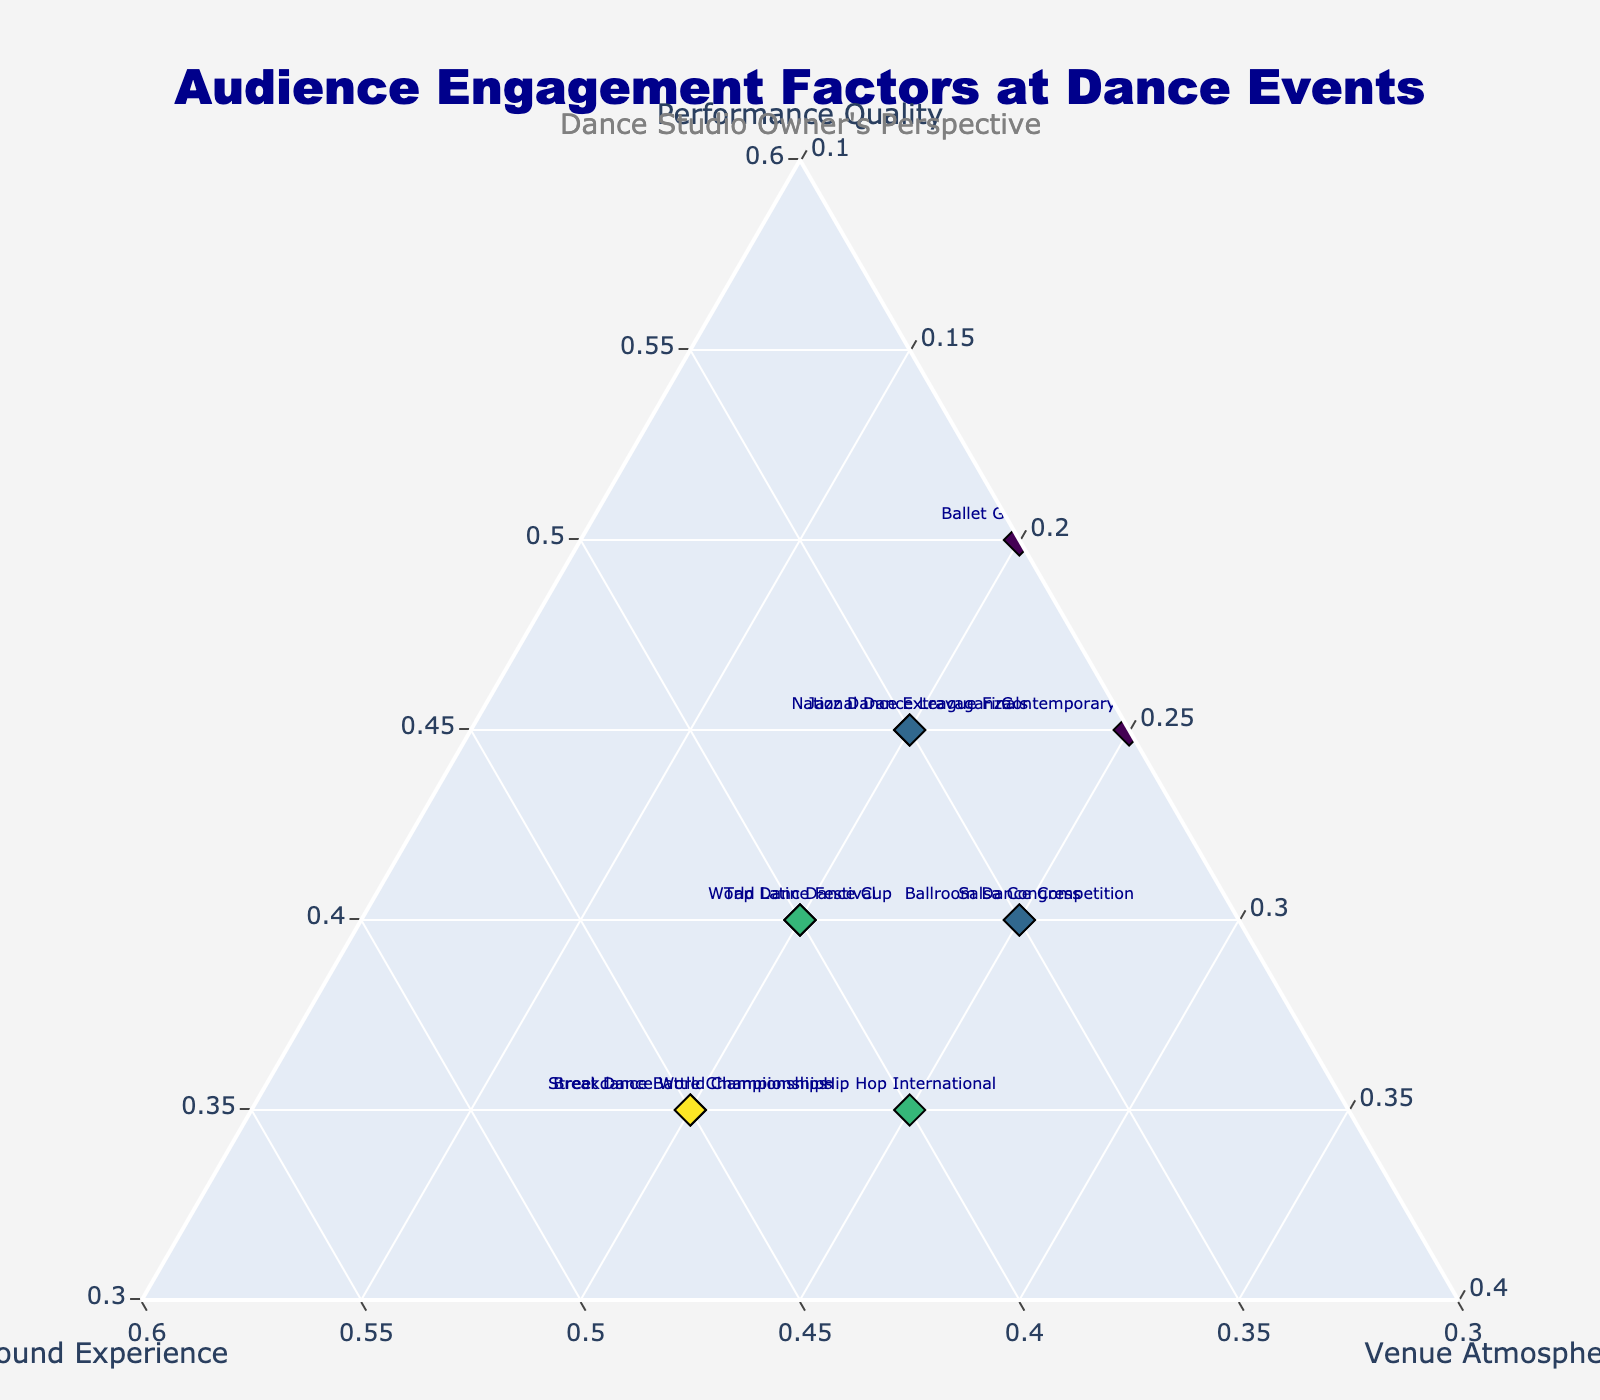what is the title of the plot? The title is usually at the top center of the plot and is written in bold or larger fonts. Looking at the plot, the title reads "Audience Engagement Factors at Dance Events".
Answer: Audience Engagement Factors at Dance Events how many events are displayed on the plot? The plot shows different events marked by text and points. Counting all the text labels for different events will give the total number, which is 11.
Answer: 11 which event has the highest sound experience score? Observing the 'Sound Experience' axis and looking for the event with the marker closest to the maximum value, the 'Breakdance Battle Championships' and 'Street Dance World Championships' both have the highest score of 0.45.
Answer: Breakdance Battle Championships, Street Dance World Championships which events have an equal contribution from performance quality and sound experience? To find events with equal values for performance quality and sound experience, check where 'a' (Performance Quality) is equal to 'b' (Sound Experience). The 'World Latin Dance Cup' and 'Tap Dance Festival' both have values of 0.40 for both factors.
Answer: World Latin Dance Cup, Tap Dance Festival which event prioritizes venue atmosphere the most? To determine this, look for the event with the highest 'Venue Atmosphere' value by checking the 'c' axis. 'Hip Hop International,' 'Salsa Congress,' 'Contemporary Dance Showcase,' and 'Ballroom Dance Competition' all have the highest 'Venue Atmosphere' score of 0.25.
Answer: Hip Hop International, Salsa Congress, Contemporary Dance Showcase, Ballroom Dance Competition what are the minimum and maximum values set for the performance quality axis? The scale for the 'Performance Quality' axis can be identified by looking at its boundary values on the plot, which are shown to be from 0.3 to 1.
Answer: min: 0.3, max: 1 what is the sum of the engagement factors for the Ballet Gala Evening? The total of performance quality, sound experience, and venue atmosphere for Ballet Gala Evening is the sum of 0.50, 0.30, and 0.20 respectively. Adding these gives 1.00.
Answer: 1.00 which factor contributes equally to audience engagement for National Dance League Finals and Jazz Dance Extravaganza? By examining the values of each factor for both events, 'Sound Experience' is at 0.35 for both 'National Dance League Finals' and 'Jazz Dance Extravaganza'.
Answer: Sound Experience comparing sound experience, which event scores higher: Hip Hop International or Contemporary Dance Showcase? Observing and comparing their respective 'Sound Experience' values, 'Hip Hop International' has 0.40 while 'Contemporary Dance Showcase' has 0.30. Therefore, 'Hip Hop International' scores higher.
Answer: Hip Hop International is there any event where the sum of Performance Quality and Sound Experience equals 0.85? We need to check each event for which the sum of 'Performance Quality' and 'Sound Experience' equals 0.85. For 'Breakdance Battle Championships,' it is 0.35 + 0.45 = 0.80, so no event meets this criterion.
Answer: No 